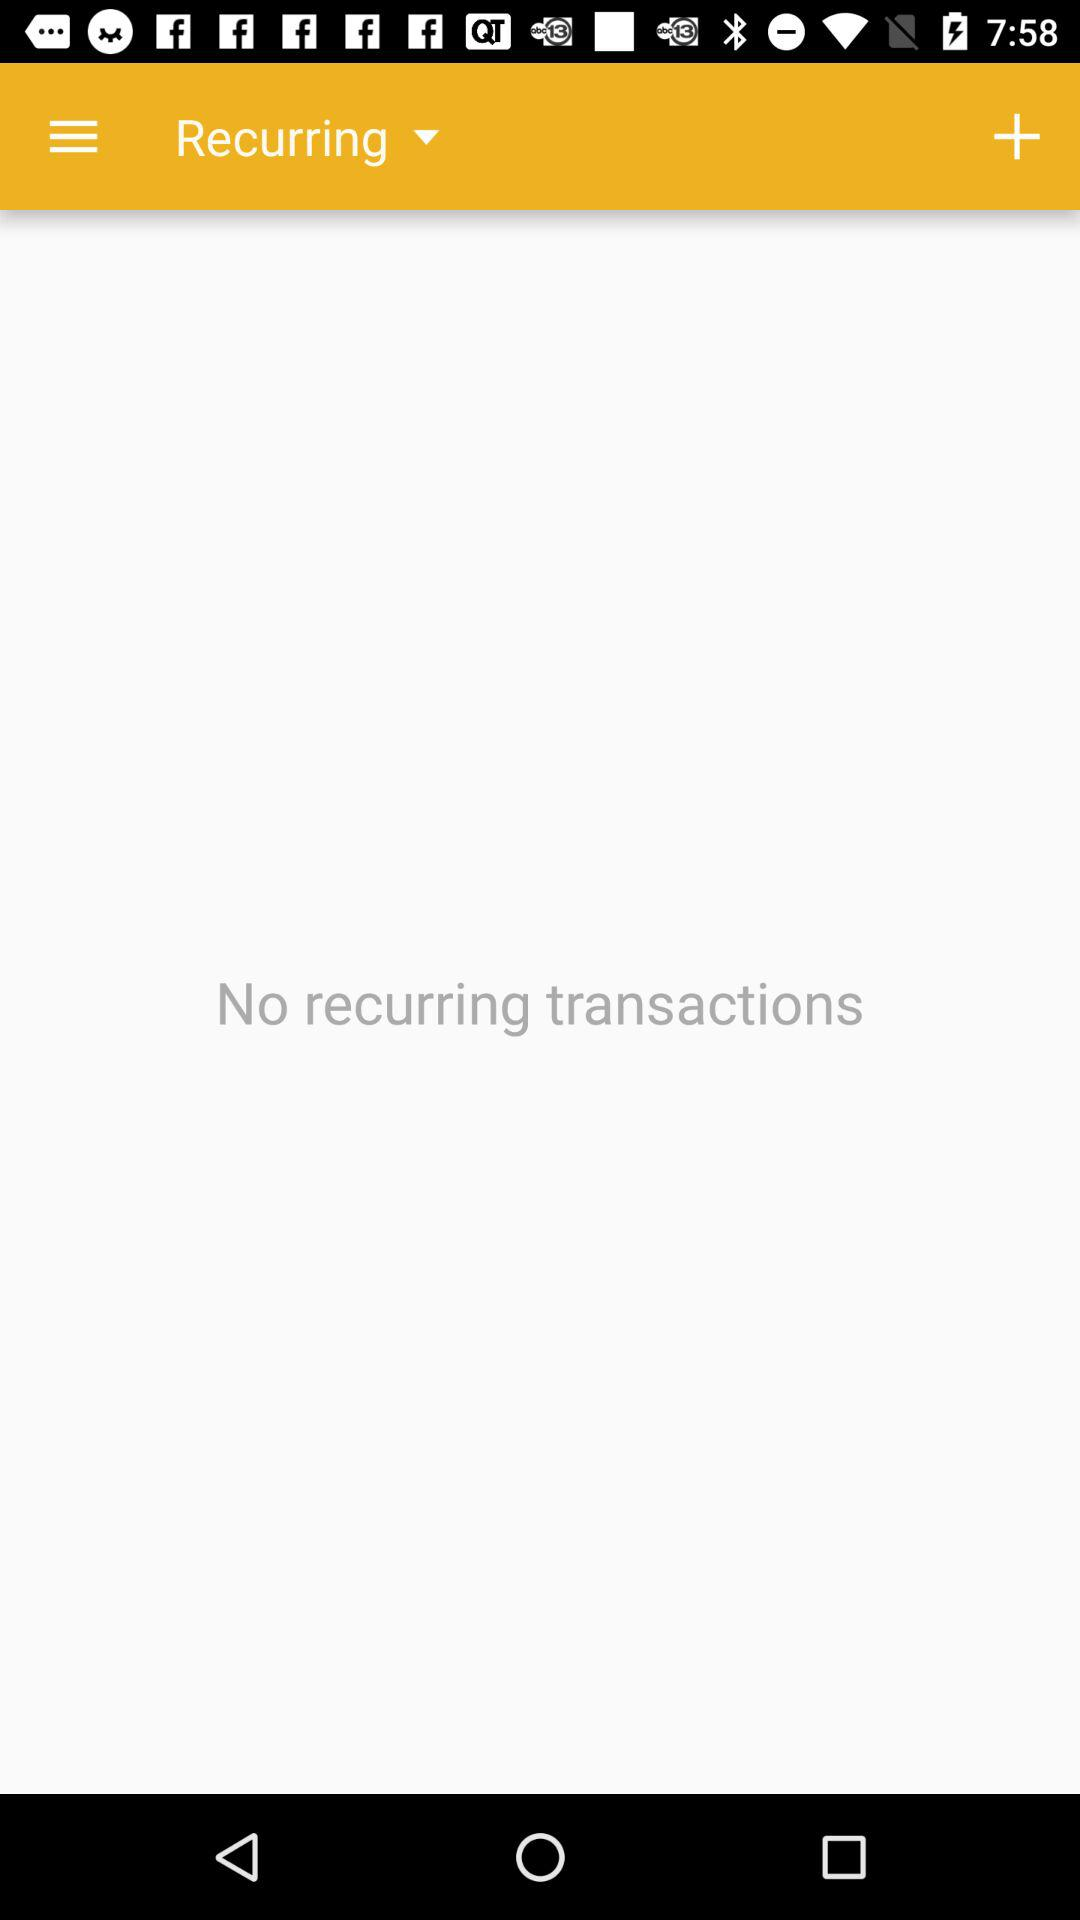What is the selected type of transaction? The selected type of transaction is "Recurring". 